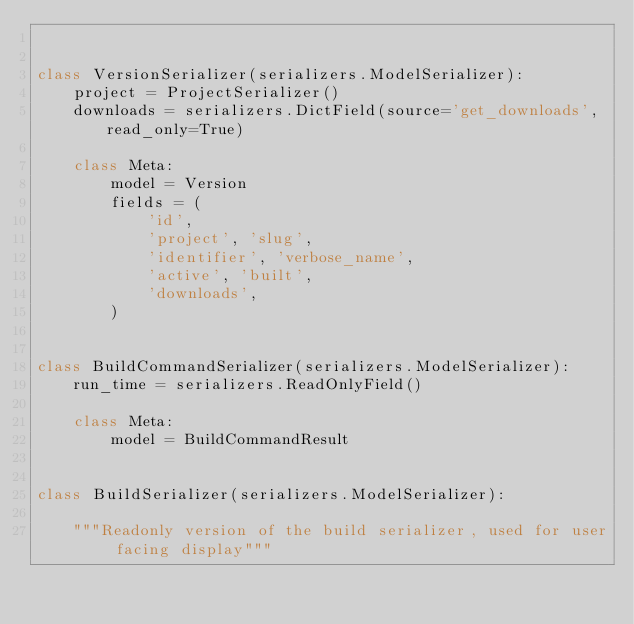Convert code to text. <code><loc_0><loc_0><loc_500><loc_500><_Python_>

class VersionSerializer(serializers.ModelSerializer):
    project = ProjectSerializer()
    downloads = serializers.DictField(source='get_downloads', read_only=True)

    class Meta:
        model = Version
        fields = (
            'id',
            'project', 'slug',
            'identifier', 'verbose_name',
            'active', 'built',
            'downloads',
        )


class BuildCommandSerializer(serializers.ModelSerializer):
    run_time = serializers.ReadOnlyField()

    class Meta:
        model = BuildCommandResult


class BuildSerializer(serializers.ModelSerializer):

    """Readonly version of the build serializer, used for user facing display"""
</code> 